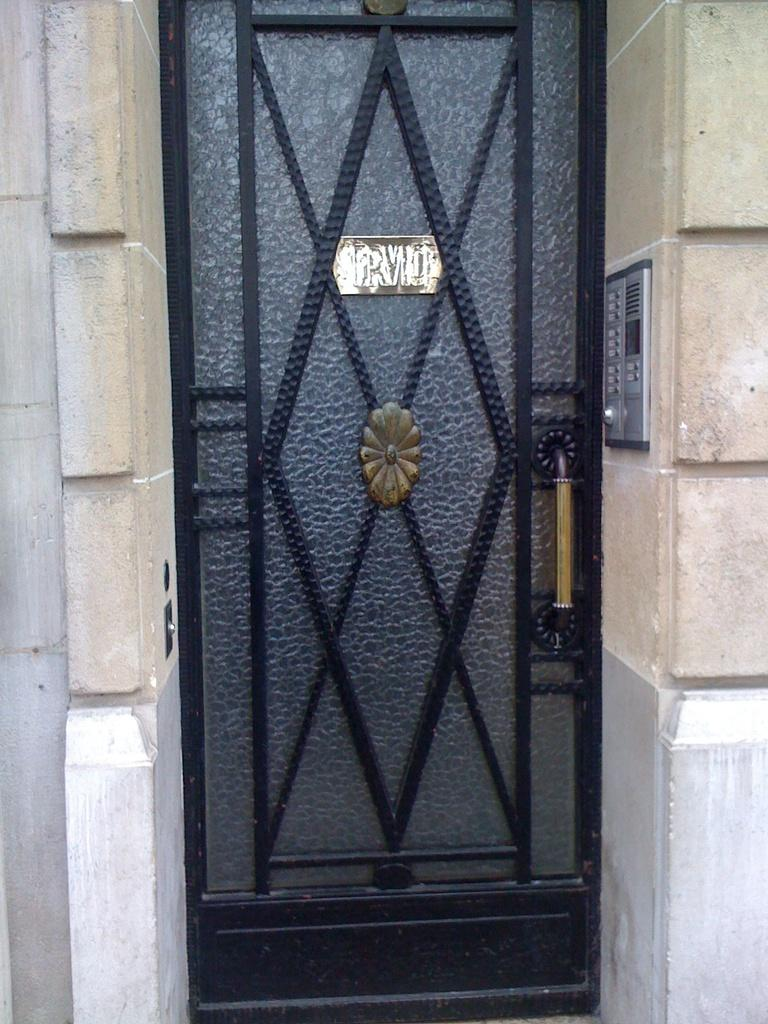What is a prominent feature in the image? There is a wall in the image. What can be found on the wall? The wall has a door and a machine attached to it. What is attached to the door? There is a board attached to the door. What is written or displayed on the board? There is text on the board. Can you tell me how the stream flows in the image? There is no stream present in the image; it features a wall with a door, a machine, and a board with text. 